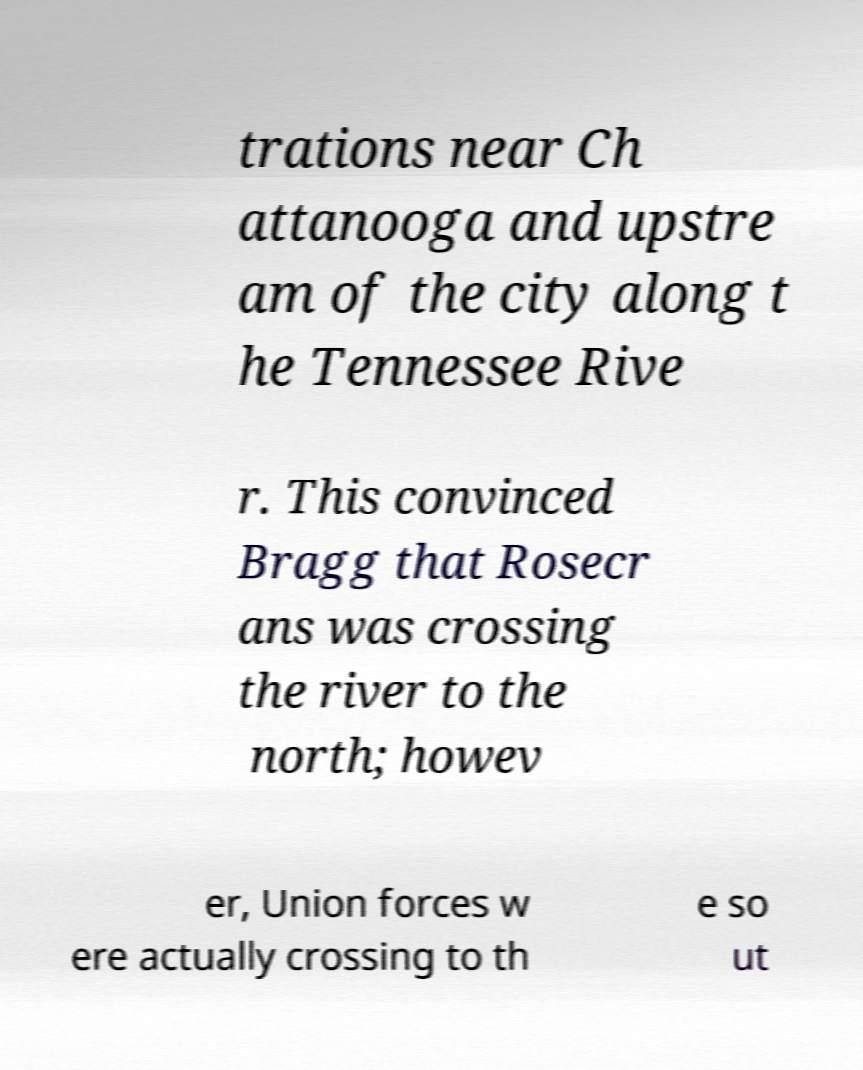Could you assist in decoding the text presented in this image and type it out clearly? trations near Ch attanooga and upstre am of the city along t he Tennessee Rive r. This convinced Bragg that Rosecr ans was crossing the river to the north; howev er, Union forces w ere actually crossing to th e so ut 